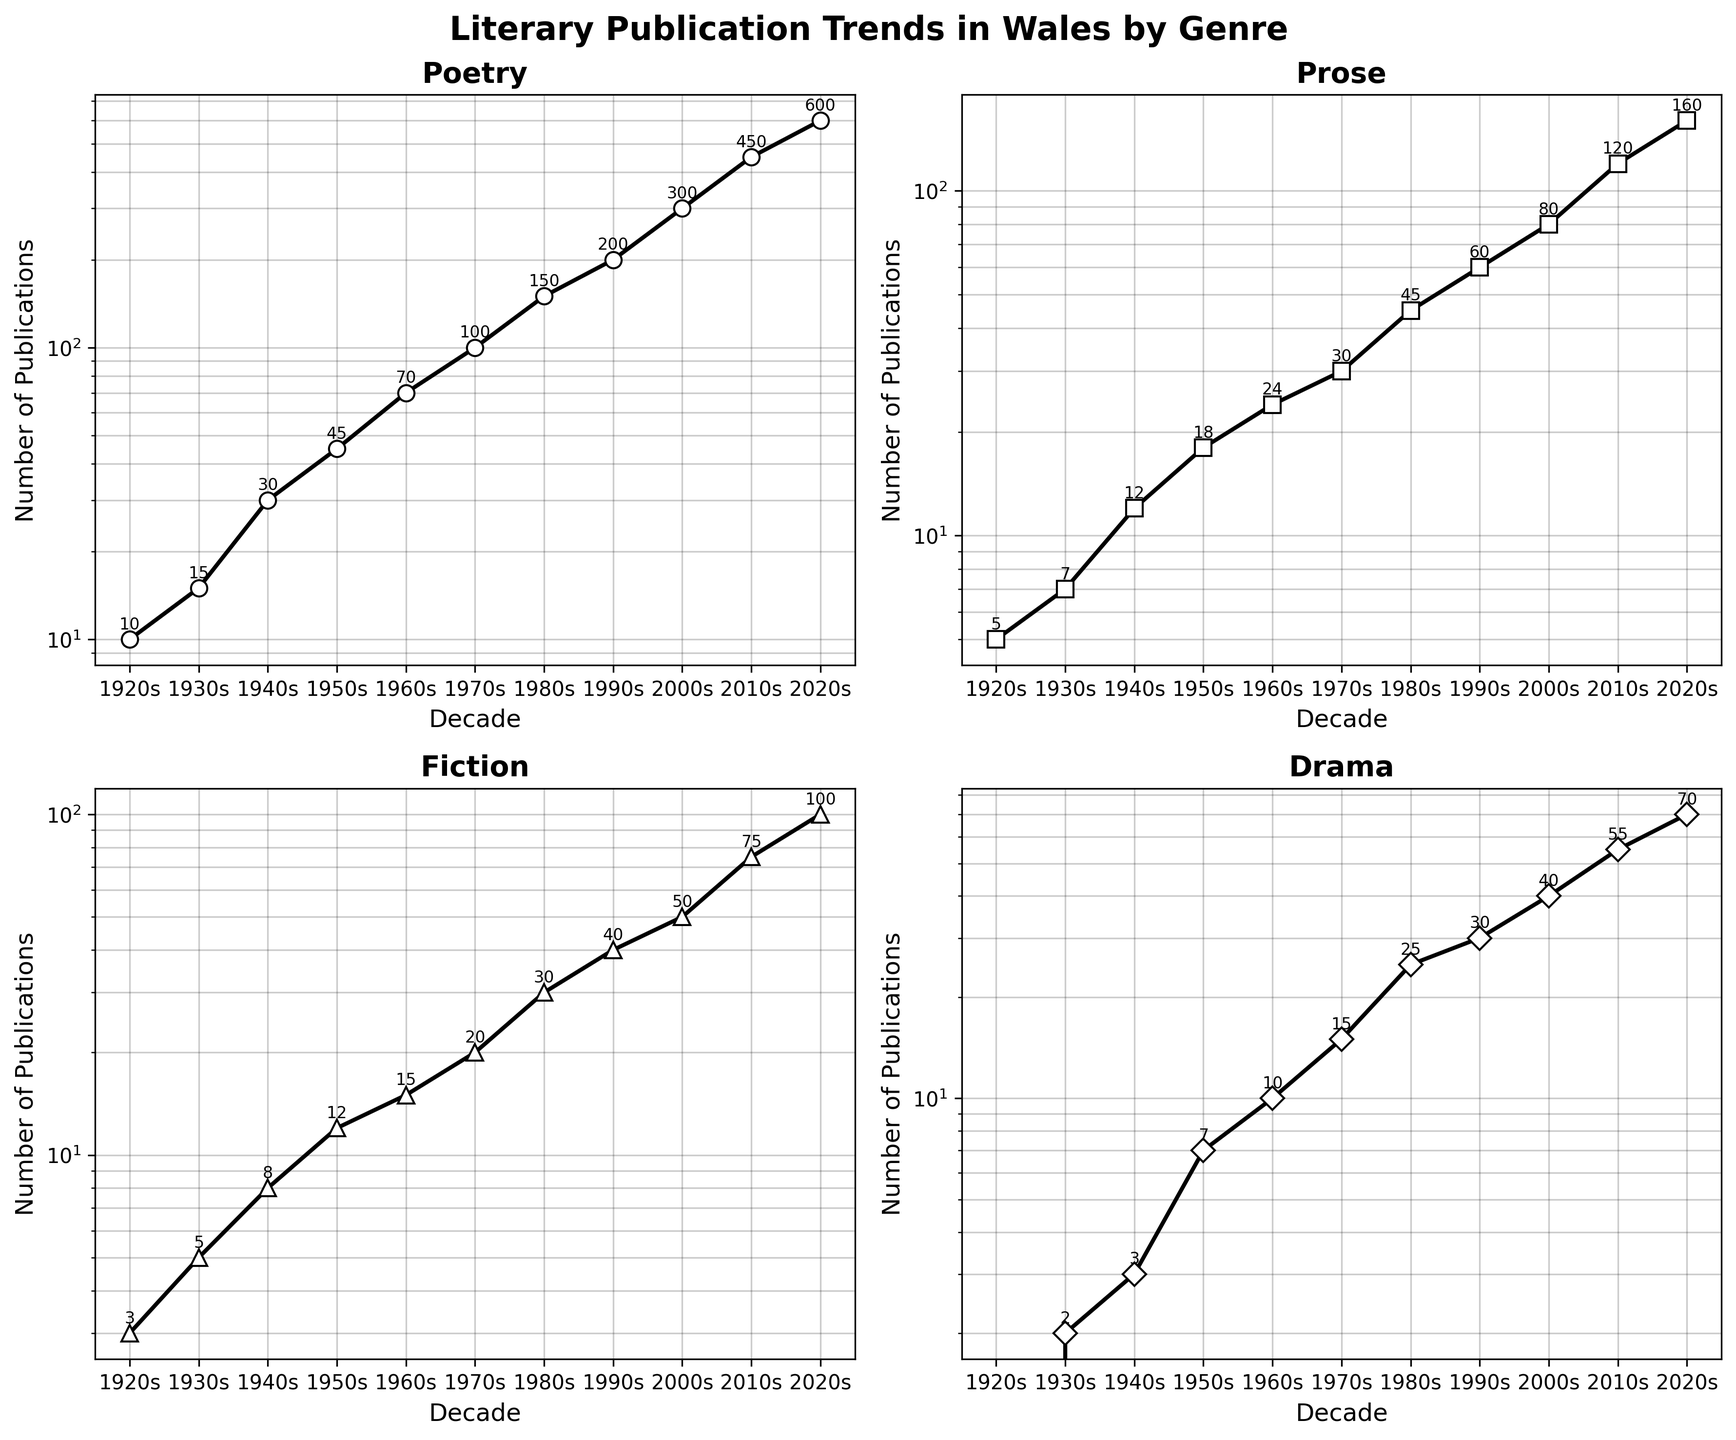What's the title of the overall figure? The title of the overall figure is located at the top of the plot. It reads 'Literary Publication Trends in Wales by Genre'.
Answer: Literary Publication Trends in Wales by Genre Which genre had the highest number of publications in the 2020s? In the subplot for each genre, the value closest to the last point (2020s) needs to be observed. Poetry shows the highest value with 600 publications.
Answer: Poetry What is the sum of the number of Prose and Fiction publications in the 1980s? To get the sum for the 1980s, add the values from the Prose plot (45) and the Fiction plot (30). 45 + 30 = 75.
Answer: 75 Compare the number of Drama publications in the 1950s and 2000s. Which decade had more? By examining the subplot for Drama, in the 1950s, there are 7 publications, while in the 2000s, there are 40 publications. The 2000s had more.
Answer: 2000s What is the average number of Fiction publications per decade from the 1960s to the 2010s? Add the number of Fiction publications from the 1960s, 1970s, 1980s, 1990s, 2000s, and 2010s. These are 15, 20, 30, 40, 50, and 75 respectively. The total is 230. Then divide by the number of decades (6): 230 / 6 = 38.33.
Answer: 38.33 Which genre saw the sharpest increase in publication numbers between two consecutive decades? Observing the changes across all subplots, the Poetry genre shows the sharpest increase between the 2010s (450) and 2020s (600). An increase of 150 publications is the highest difference.
Answer: Poetry What is the smallest value represented on all subplots? The smallest values can be found by checking the initial data points in each subplot. The smallest value across all genres and decades is '0' in the Drama subplot for the 1920s.
Answer: 0 